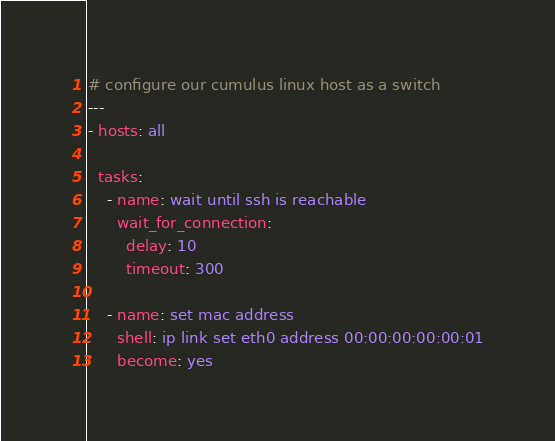<code> <loc_0><loc_0><loc_500><loc_500><_YAML_># configure our cumulus linux host as a switch
---
- hosts: all

  tasks:
    - name: wait until ssh is reachable
      wait_for_connection:
        delay: 10
        timeout: 300

    - name: set mac address
      shell: ip link set eth0 address 00:00:00:00:00:01
      become: yes
</code> 